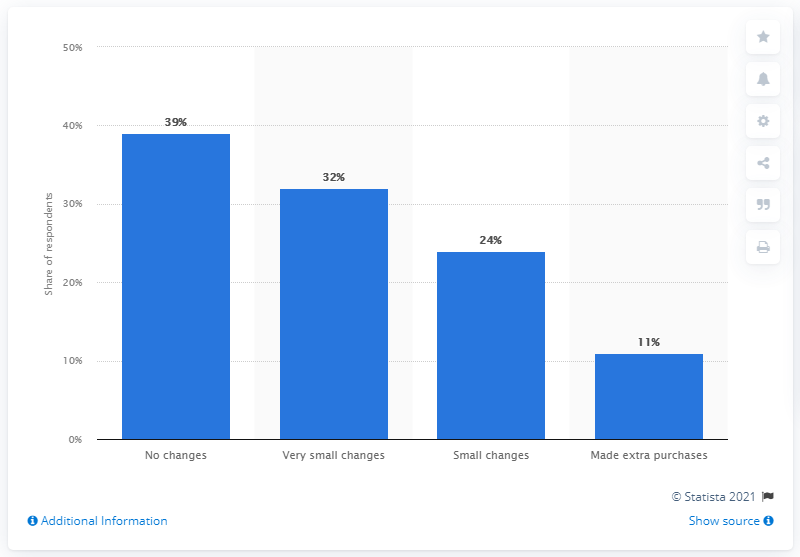Identify some key points in this picture. According to a recent survey, over 11% of Dutch people reported making additional purchases in March 2020. 